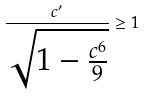Convert formula to latex. <formula><loc_0><loc_0><loc_500><loc_500>\frac { c ^ { \prime } } { \sqrt { 1 - \frac { c ^ { 6 } } { 9 } } } \geq 1</formula> 